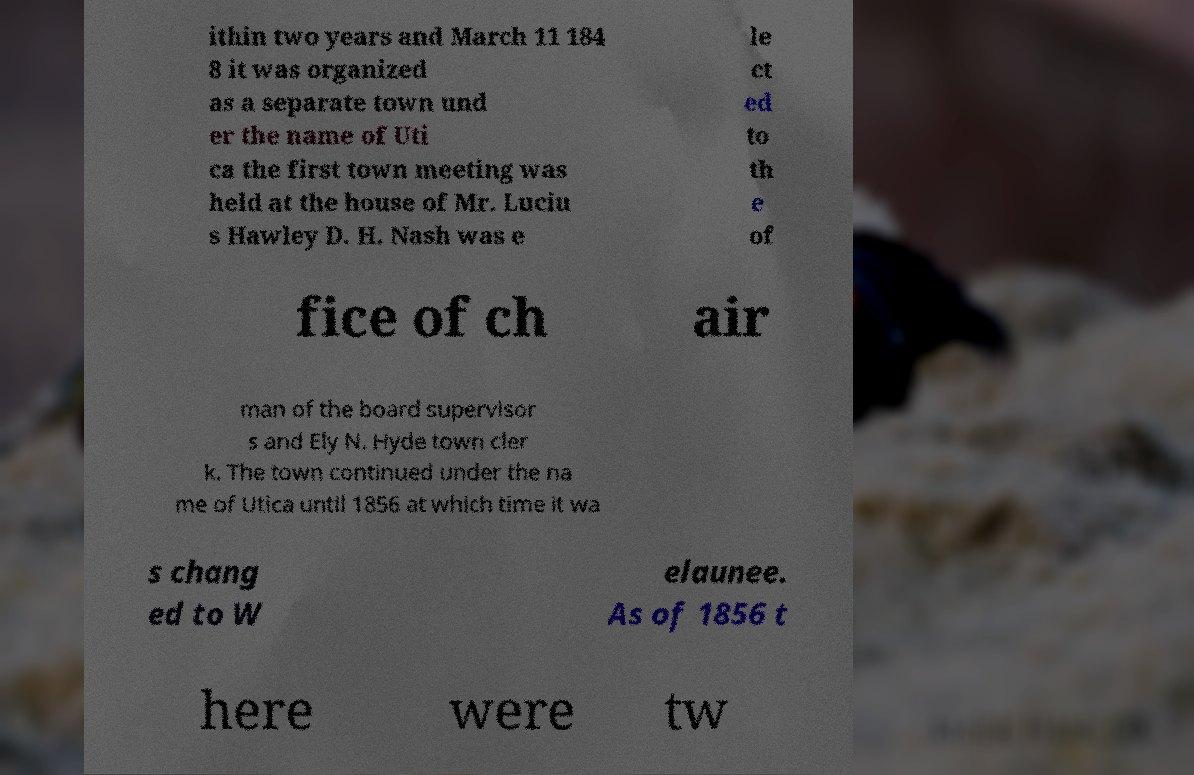I need the written content from this picture converted into text. Can you do that? ithin two years and March 11 184 8 it was organized as a separate town und er the name of Uti ca the first town meeting was held at the house of Mr. Luciu s Hawley D. H. Nash was e le ct ed to th e of fice of ch air man of the board supervisor s and Ely N. Hyde town cler k. The town continued under the na me of Utica until 1856 at which time it wa s chang ed to W elaunee. As of 1856 t here were tw 